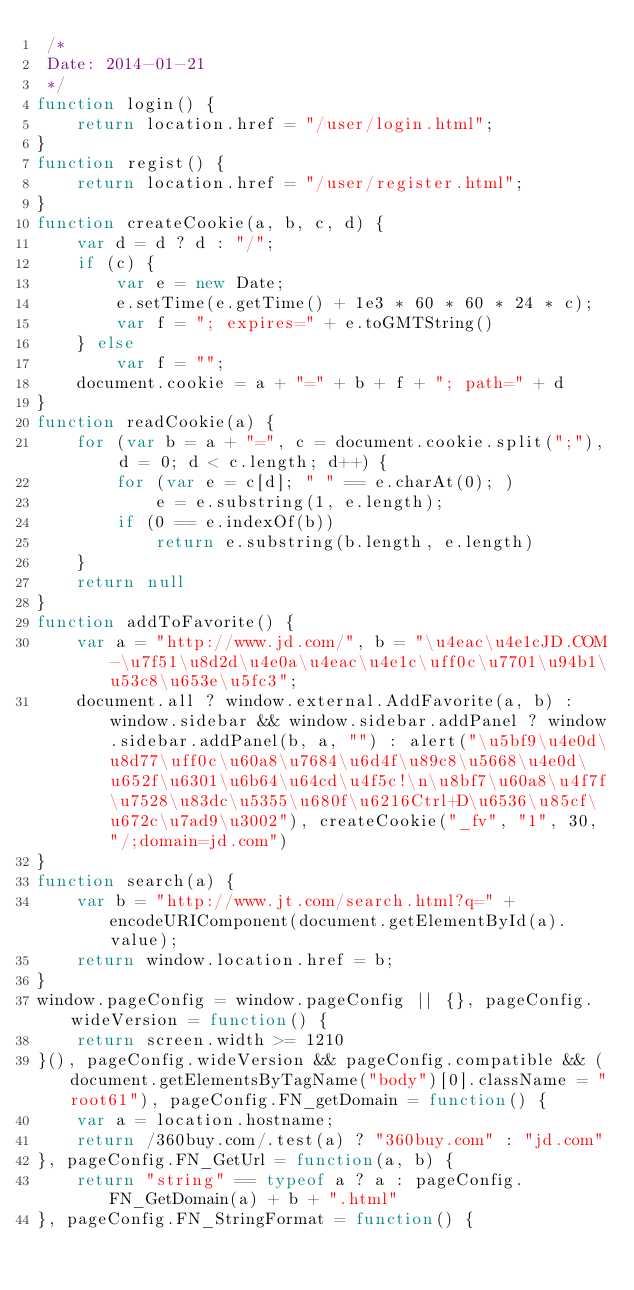<code> <loc_0><loc_0><loc_500><loc_500><_JavaScript_> /*
 Date: 2014-01-21 
 */
function login() {
    return location.href = "/user/login.html";
}
function regist() {
    return location.href = "/user/register.html";
}
function createCookie(a, b, c, d) {
    var d = d ? d : "/";
    if (c) {
        var e = new Date;
        e.setTime(e.getTime() + 1e3 * 60 * 60 * 24 * c);
        var f = "; expires=" + e.toGMTString()
    } else
        var f = "";
    document.cookie = a + "=" + b + f + "; path=" + d
}
function readCookie(a) {
    for (var b = a + "=", c = document.cookie.split(";"), d = 0; d < c.length; d++) {
        for (var e = c[d]; " " == e.charAt(0); )
            e = e.substring(1, e.length);
        if (0 == e.indexOf(b))
            return e.substring(b.length, e.length)
    }
    return null
}
function addToFavorite() {
    var a = "http://www.jd.com/", b = "\u4eac\u4e1cJD.COM-\u7f51\u8d2d\u4e0a\u4eac\u4e1c\uff0c\u7701\u94b1\u53c8\u653e\u5fc3";
    document.all ? window.external.AddFavorite(a, b) : window.sidebar && window.sidebar.addPanel ? window.sidebar.addPanel(b, a, "") : alert("\u5bf9\u4e0d\u8d77\uff0c\u60a8\u7684\u6d4f\u89c8\u5668\u4e0d\u652f\u6301\u6b64\u64cd\u4f5c!\n\u8bf7\u60a8\u4f7f\u7528\u83dc\u5355\u680f\u6216Ctrl+D\u6536\u85cf\u672c\u7ad9\u3002"), createCookie("_fv", "1", 30, "/;domain=jd.com")
}
function search(a) {
    var b = "http://www.jt.com/search.html?q=" + encodeURIComponent(document.getElementById(a).value);
    return window.location.href = b;
}
window.pageConfig = window.pageConfig || {}, pageConfig.wideVersion = function() {
    return screen.width >= 1210
}(), pageConfig.wideVersion && pageConfig.compatible && (document.getElementsByTagName("body")[0].className = "root61"), pageConfig.FN_getDomain = function() {
    var a = location.hostname;
    return /360buy.com/.test(a) ? "360buy.com" : "jd.com"
}, pageConfig.FN_GetUrl = function(a, b) {
    return "string" == typeof a ? a : pageConfig.FN_GetDomain(a) + b + ".html"
}, pageConfig.FN_StringFormat = function() {</code> 